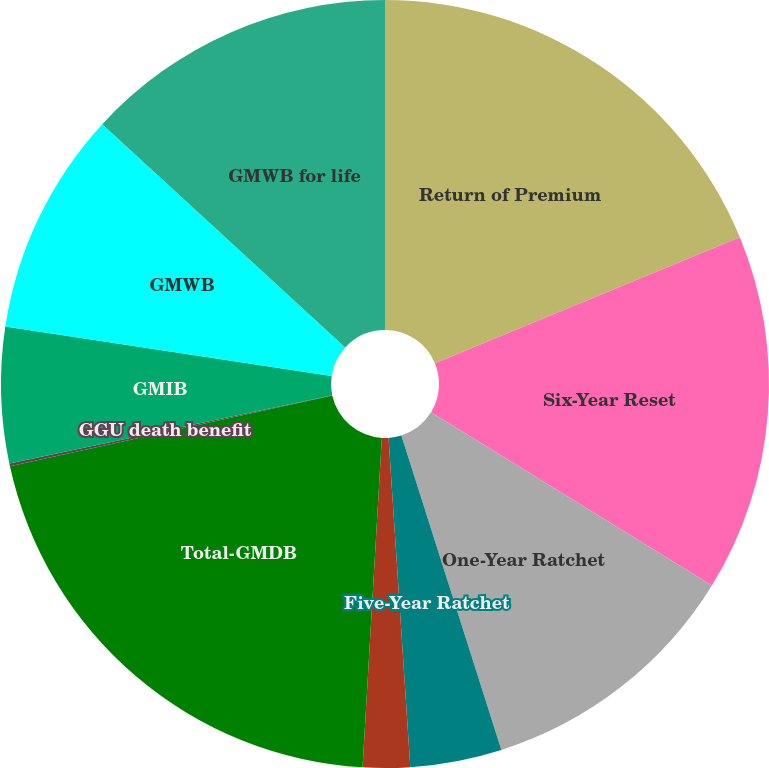Convert chart. <chart><loc_0><loc_0><loc_500><loc_500><pie_chart><fcel>Return of Premium<fcel>Six-Year Reset<fcel>One-Year Ratchet<fcel>Five-Year Ratchet<fcel>Other<fcel>Total-GMDB<fcel>GGU death benefit<fcel>GMIB<fcel>GMWB<fcel>GMWB for life<nl><fcel>18.76%<fcel>15.03%<fcel>11.31%<fcel>3.85%<fcel>1.98%<fcel>20.63%<fcel>0.12%<fcel>5.71%<fcel>9.44%<fcel>13.17%<nl></chart> 